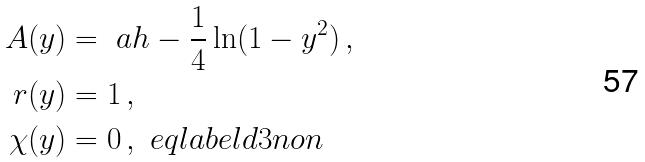<formula> <loc_0><loc_0><loc_500><loc_500>A ( y ) & = \ a h - \frac { 1 } { 4 } \ln ( 1 - y ^ { 2 } ) \, , \\ \ r ( y ) & = 1 \, , \\ \chi ( y ) & = 0 \, , \ e q l a b e l { d 3 n o n }</formula> 